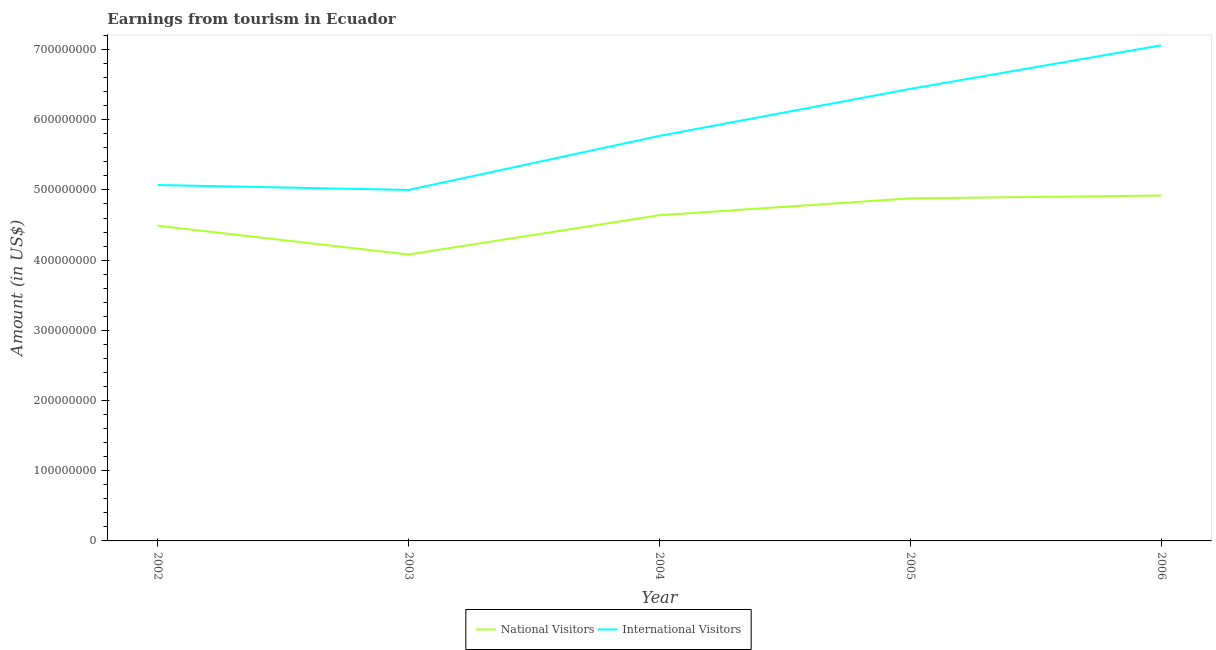Does the line corresponding to amount earned from international visitors intersect with the line corresponding to amount earned from national visitors?
Give a very brief answer. No. What is the amount earned from national visitors in 2005?
Provide a succinct answer. 4.88e+08. Across all years, what is the maximum amount earned from national visitors?
Provide a succinct answer. 4.92e+08. Across all years, what is the minimum amount earned from national visitors?
Your response must be concise. 4.08e+08. What is the total amount earned from international visitors in the graph?
Provide a succinct answer. 2.93e+09. What is the difference between the amount earned from national visitors in 2004 and that in 2005?
Offer a terse response. -2.40e+07. What is the difference between the amount earned from national visitors in 2004 and the amount earned from international visitors in 2006?
Ensure brevity in your answer.  -2.42e+08. What is the average amount earned from international visitors per year?
Make the answer very short. 5.87e+08. In the year 2003, what is the difference between the amount earned from international visitors and amount earned from national visitors?
Your response must be concise. 9.20e+07. What is the ratio of the amount earned from national visitors in 2002 to that in 2006?
Your response must be concise. 0.91. Is the amount earned from national visitors in 2003 less than that in 2006?
Keep it short and to the point. Yes. What is the difference between the highest and the lowest amount earned from national visitors?
Make the answer very short. 8.40e+07. In how many years, is the amount earned from international visitors greater than the average amount earned from international visitors taken over all years?
Offer a very short reply. 2. Is the sum of the amount earned from national visitors in 2004 and 2005 greater than the maximum amount earned from international visitors across all years?
Your response must be concise. Yes. Is the amount earned from international visitors strictly less than the amount earned from national visitors over the years?
Offer a very short reply. No. How many lines are there?
Your answer should be very brief. 2. Are the values on the major ticks of Y-axis written in scientific E-notation?
Give a very brief answer. No. Does the graph contain any zero values?
Give a very brief answer. No. Does the graph contain grids?
Keep it short and to the point. No. How many legend labels are there?
Ensure brevity in your answer.  2. What is the title of the graph?
Your answer should be very brief. Earnings from tourism in Ecuador. What is the label or title of the X-axis?
Your answer should be very brief. Year. What is the Amount (in US$) of National Visitors in 2002?
Offer a very short reply. 4.49e+08. What is the Amount (in US$) in International Visitors in 2002?
Keep it short and to the point. 5.07e+08. What is the Amount (in US$) of National Visitors in 2003?
Give a very brief answer. 4.08e+08. What is the Amount (in US$) in International Visitors in 2003?
Provide a succinct answer. 5.00e+08. What is the Amount (in US$) of National Visitors in 2004?
Keep it short and to the point. 4.64e+08. What is the Amount (in US$) in International Visitors in 2004?
Your answer should be very brief. 5.77e+08. What is the Amount (in US$) in National Visitors in 2005?
Give a very brief answer. 4.88e+08. What is the Amount (in US$) of International Visitors in 2005?
Ensure brevity in your answer.  6.44e+08. What is the Amount (in US$) of National Visitors in 2006?
Make the answer very short. 4.92e+08. What is the Amount (in US$) of International Visitors in 2006?
Your answer should be very brief. 7.06e+08. Across all years, what is the maximum Amount (in US$) of National Visitors?
Your answer should be compact. 4.92e+08. Across all years, what is the maximum Amount (in US$) of International Visitors?
Offer a very short reply. 7.06e+08. Across all years, what is the minimum Amount (in US$) of National Visitors?
Give a very brief answer. 4.08e+08. Across all years, what is the minimum Amount (in US$) in International Visitors?
Provide a succinct answer. 5.00e+08. What is the total Amount (in US$) in National Visitors in the graph?
Provide a short and direct response. 2.30e+09. What is the total Amount (in US$) in International Visitors in the graph?
Make the answer very short. 2.93e+09. What is the difference between the Amount (in US$) of National Visitors in 2002 and that in 2003?
Your answer should be compact. 4.10e+07. What is the difference between the Amount (in US$) in International Visitors in 2002 and that in 2003?
Offer a terse response. 7.00e+06. What is the difference between the Amount (in US$) of National Visitors in 2002 and that in 2004?
Your response must be concise. -1.50e+07. What is the difference between the Amount (in US$) in International Visitors in 2002 and that in 2004?
Provide a succinct answer. -7.00e+07. What is the difference between the Amount (in US$) in National Visitors in 2002 and that in 2005?
Offer a terse response. -3.90e+07. What is the difference between the Amount (in US$) of International Visitors in 2002 and that in 2005?
Keep it short and to the point. -1.37e+08. What is the difference between the Amount (in US$) in National Visitors in 2002 and that in 2006?
Ensure brevity in your answer.  -4.30e+07. What is the difference between the Amount (in US$) in International Visitors in 2002 and that in 2006?
Your response must be concise. -1.99e+08. What is the difference between the Amount (in US$) of National Visitors in 2003 and that in 2004?
Your answer should be very brief. -5.60e+07. What is the difference between the Amount (in US$) in International Visitors in 2003 and that in 2004?
Keep it short and to the point. -7.70e+07. What is the difference between the Amount (in US$) of National Visitors in 2003 and that in 2005?
Ensure brevity in your answer.  -8.00e+07. What is the difference between the Amount (in US$) in International Visitors in 2003 and that in 2005?
Ensure brevity in your answer.  -1.44e+08. What is the difference between the Amount (in US$) of National Visitors in 2003 and that in 2006?
Give a very brief answer. -8.40e+07. What is the difference between the Amount (in US$) in International Visitors in 2003 and that in 2006?
Ensure brevity in your answer.  -2.06e+08. What is the difference between the Amount (in US$) of National Visitors in 2004 and that in 2005?
Keep it short and to the point. -2.40e+07. What is the difference between the Amount (in US$) of International Visitors in 2004 and that in 2005?
Offer a very short reply. -6.70e+07. What is the difference between the Amount (in US$) of National Visitors in 2004 and that in 2006?
Offer a very short reply. -2.80e+07. What is the difference between the Amount (in US$) in International Visitors in 2004 and that in 2006?
Your answer should be very brief. -1.29e+08. What is the difference between the Amount (in US$) in National Visitors in 2005 and that in 2006?
Your answer should be compact. -4.00e+06. What is the difference between the Amount (in US$) of International Visitors in 2005 and that in 2006?
Provide a short and direct response. -6.20e+07. What is the difference between the Amount (in US$) in National Visitors in 2002 and the Amount (in US$) in International Visitors in 2003?
Provide a short and direct response. -5.10e+07. What is the difference between the Amount (in US$) of National Visitors in 2002 and the Amount (in US$) of International Visitors in 2004?
Your answer should be compact. -1.28e+08. What is the difference between the Amount (in US$) of National Visitors in 2002 and the Amount (in US$) of International Visitors in 2005?
Ensure brevity in your answer.  -1.95e+08. What is the difference between the Amount (in US$) of National Visitors in 2002 and the Amount (in US$) of International Visitors in 2006?
Make the answer very short. -2.57e+08. What is the difference between the Amount (in US$) of National Visitors in 2003 and the Amount (in US$) of International Visitors in 2004?
Offer a very short reply. -1.69e+08. What is the difference between the Amount (in US$) of National Visitors in 2003 and the Amount (in US$) of International Visitors in 2005?
Provide a succinct answer. -2.36e+08. What is the difference between the Amount (in US$) of National Visitors in 2003 and the Amount (in US$) of International Visitors in 2006?
Offer a very short reply. -2.98e+08. What is the difference between the Amount (in US$) in National Visitors in 2004 and the Amount (in US$) in International Visitors in 2005?
Keep it short and to the point. -1.80e+08. What is the difference between the Amount (in US$) in National Visitors in 2004 and the Amount (in US$) in International Visitors in 2006?
Your answer should be very brief. -2.42e+08. What is the difference between the Amount (in US$) in National Visitors in 2005 and the Amount (in US$) in International Visitors in 2006?
Your answer should be compact. -2.18e+08. What is the average Amount (in US$) in National Visitors per year?
Your response must be concise. 4.60e+08. What is the average Amount (in US$) in International Visitors per year?
Your answer should be compact. 5.87e+08. In the year 2002, what is the difference between the Amount (in US$) of National Visitors and Amount (in US$) of International Visitors?
Offer a terse response. -5.80e+07. In the year 2003, what is the difference between the Amount (in US$) of National Visitors and Amount (in US$) of International Visitors?
Your answer should be very brief. -9.20e+07. In the year 2004, what is the difference between the Amount (in US$) of National Visitors and Amount (in US$) of International Visitors?
Provide a short and direct response. -1.13e+08. In the year 2005, what is the difference between the Amount (in US$) in National Visitors and Amount (in US$) in International Visitors?
Your answer should be very brief. -1.56e+08. In the year 2006, what is the difference between the Amount (in US$) in National Visitors and Amount (in US$) in International Visitors?
Offer a very short reply. -2.14e+08. What is the ratio of the Amount (in US$) of National Visitors in 2002 to that in 2003?
Offer a very short reply. 1.1. What is the ratio of the Amount (in US$) of International Visitors in 2002 to that in 2003?
Offer a very short reply. 1.01. What is the ratio of the Amount (in US$) of National Visitors in 2002 to that in 2004?
Offer a terse response. 0.97. What is the ratio of the Amount (in US$) in International Visitors in 2002 to that in 2004?
Offer a terse response. 0.88. What is the ratio of the Amount (in US$) in National Visitors in 2002 to that in 2005?
Make the answer very short. 0.92. What is the ratio of the Amount (in US$) in International Visitors in 2002 to that in 2005?
Your answer should be compact. 0.79. What is the ratio of the Amount (in US$) in National Visitors in 2002 to that in 2006?
Your answer should be compact. 0.91. What is the ratio of the Amount (in US$) in International Visitors in 2002 to that in 2006?
Ensure brevity in your answer.  0.72. What is the ratio of the Amount (in US$) in National Visitors in 2003 to that in 2004?
Provide a short and direct response. 0.88. What is the ratio of the Amount (in US$) of International Visitors in 2003 to that in 2004?
Offer a very short reply. 0.87. What is the ratio of the Amount (in US$) of National Visitors in 2003 to that in 2005?
Make the answer very short. 0.84. What is the ratio of the Amount (in US$) in International Visitors in 2003 to that in 2005?
Your answer should be compact. 0.78. What is the ratio of the Amount (in US$) in National Visitors in 2003 to that in 2006?
Your answer should be very brief. 0.83. What is the ratio of the Amount (in US$) in International Visitors in 2003 to that in 2006?
Offer a terse response. 0.71. What is the ratio of the Amount (in US$) in National Visitors in 2004 to that in 2005?
Your answer should be very brief. 0.95. What is the ratio of the Amount (in US$) of International Visitors in 2004 to that in 2005?
Keep it short and to the point. 0.9. What is the ratio of the Amount (in US$) in National Visitors in 2004 to that in 2006?
Offer a terse response. 0.94. What is the ratio of the Amount (in US$) of International Visitors in 2004 to that in 2006?
Ensure brevity in your answer.  0.82. What is the ratio of the Amount (in US$) of International Visitors in 2005 to that in 2006?
Your answer should be compact. 0.91. What is the difference between the highest and the second highest Amount (in US$) of National Visitors?
Make the answer very short. 4.00e+06. What is the difference between the highest and the second highest Amount (in US$) of International Visitors?
Ensure brevity in your answer.  6.20e+07. What is the difference between the highest and the lowest Amount (in US$) in National Visitors?
Keep it short and to the point. 8.40e+07. What is the difference between the highest and the lowest Amount (in US$) of International Visitors?
Your response must be concise. 2.06e+08. 